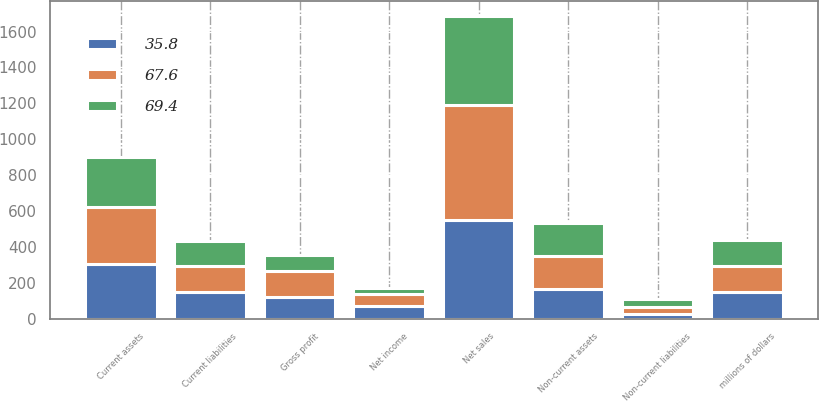Convert chart to OTSL. <chart><loc_0><loc_0><loc_500><loc_500><stacked_bar_chart><ecel><fcel>millions of dollars<fcel>Current assets<fcel>Non-current assets<fcel>Current liabilities<fcel>Non-current liabilities<fcel>Net sales<fcel>Gross profit<fcel>Net income<nl><fcel>69.4<fcel>146.3<fcel>279.1<fcel>182.6<fcel>137.9<fcel>45<fcel>494.5<fcel>89.2<fcel>35.8<nl><fcel>67.6<fcel>146.3<fcel>319.1<fcel>185.7<fcel>146.3<fcel>40.5<fcel>637.9<fcel>140<fcel>67.6<nl><fcel>35.8<fcel>146.3<fcel>304.6<fcel>164.3<fcel>148.8<fcel>22.9<fcel>552.1<fcel>122.7<fcel>69.4<nl></chart> 